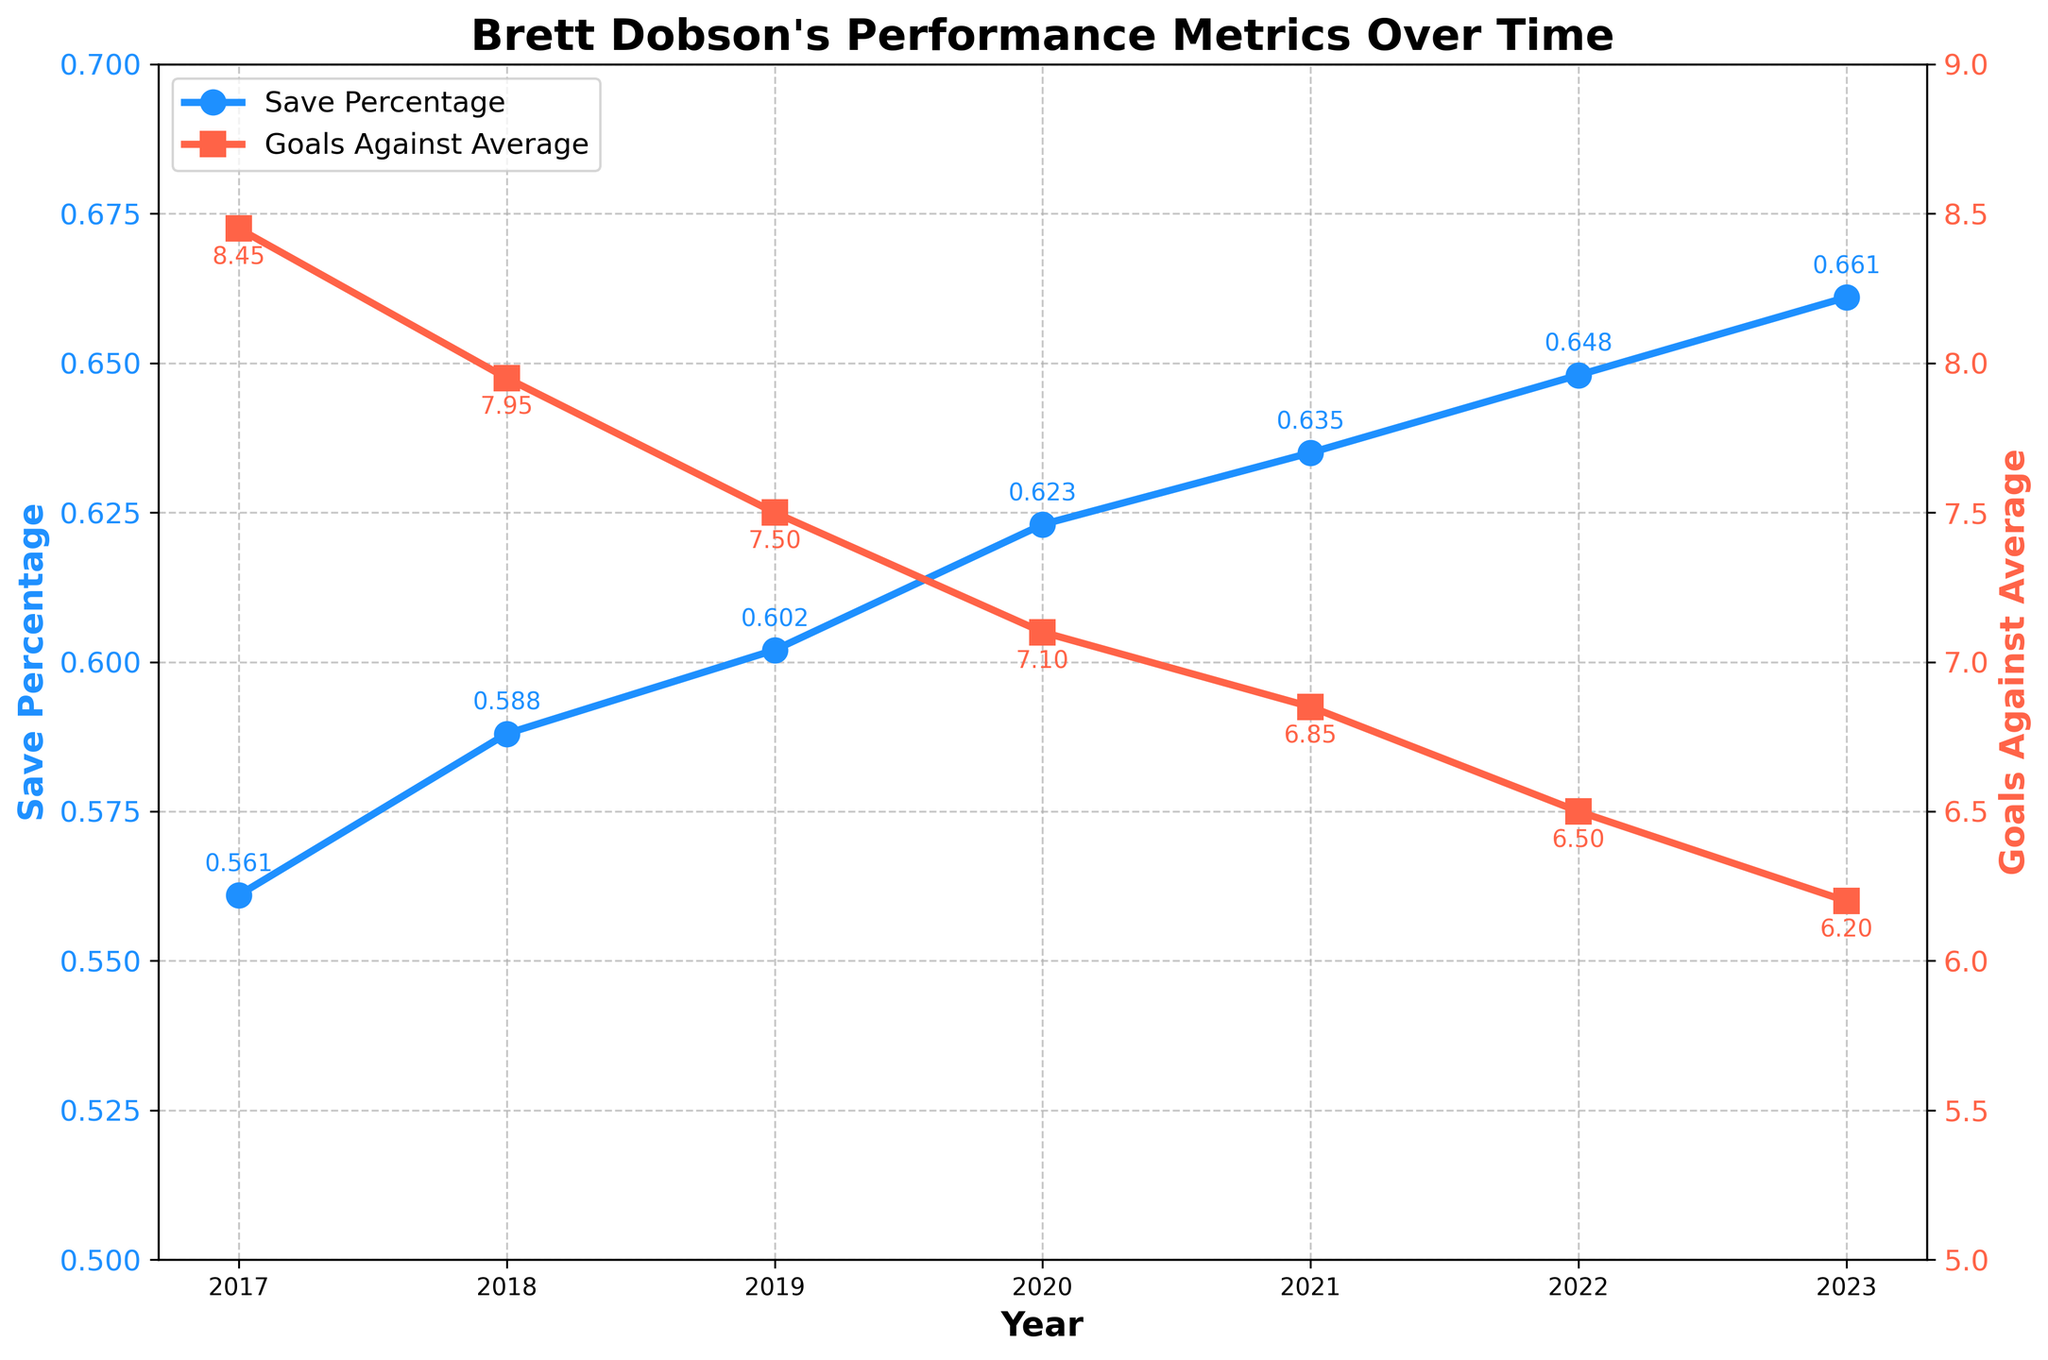What is the title of the plot? The title is usually placed at the top of the plot and is in bold font. In this plot, the title is indicated above the main chart.
Answer: Brett Dobson's Performance Metrics Over Time How many years of data are presented in the plot? The x-axis represents the timeline, which ranges from 2017 to 2023. By counting each year, we get the total number of data points.
Answer: 7 What was Brett Dobson's save percentage in 2019? Locate the point on the blue line (save percentage) corresponding to the year 2019. The y-axis shows the value.
Answer: 0.602 Which year shows the highest save percentage? Look at the highest point on the blue line and check the corresponding year on the x-axis. This highest point represents the maximum save percentage.
Answer: 2023 How much did the goals against average (GAA) decrease from 2017 to 2023? Identify the GAA values for both 2017 and 2023 from the red line on the plot. Calculate the difference: 8.45 (2017) - 6.20 (2023).
Answer: 2.25 What is the trend in Brett Dobson's goals against average over the years? Observe the pattern of the red line representing the goals against average. The line consistently moves downward from 2017 to 2023, indicating a decreasing trend.
Answer: Decreasing In which year did Brett Dobson's save percentage surpass 0.60 for the first time? Locate the first instance where the blue line (save percentage) crosses the 0.60 mark on the y-axis and identify the corresponding year.
Answer: 2019 Which year had the lowest goals against average? Find the lowest point on the red line and note the corresponding year on the x-axis.
Answer: 2023 What is the difference between the save percentage in 2022 and 2023? Identify the save percentages for 2022 and 2023 and then subtract the 2022 value from the 2023 value.
Answer: 0.013 Is there a year where both save percentage and goals against average remained the same compared to the previous year? Examine the plot to see if there is any year where consecutive points (for both blue and red lines) are at the same level as the previous year’s points.
Answer: No 